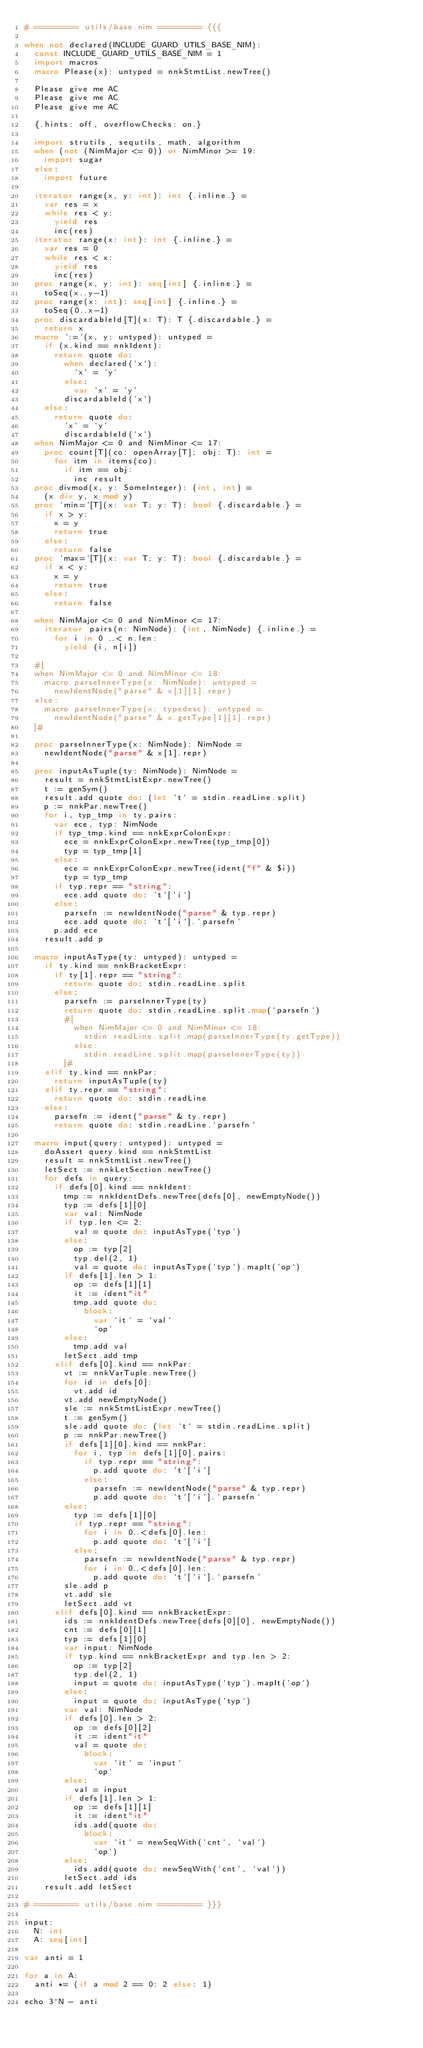Convert code to text. <code><loc_0><loc_0><loc_500><loc_500><_Nim_># ========= utils/base.nim ========= {{{

when not declared(INCLUDE_GUARD_UTILS_BASE_NIM):
  const INCLUDE_GUARD_UTILS_BASE_NIM = 1
  import macros
  macro Please(x): untyped = nnkStmtList.newTree()

  Please give me AC
  Please give me AC
  Please give me AC

  {.hints: off, overflowChecks: on.}

  import strutils, sequtils, math, algorithm
  when (not (NimMajor <= 0)) or NimMinor >= 19:
    import sugar
  else:
    import future

  iterator range(x, y: int): int {.inline.} =
    var res = x
    while res < y:
      yield res
      inc(res)
  iterator range(x: int): int {.inline.} =
    var res = 0
    while res < x:
      yield res
      inc(res)
  proc range(x, y: int): seq[int] {.inline.} =
    toSeq(x..y-1)
  proc range(x: int): seq[int] {.inline.} =
    toSeq(0..x-1)
  proc discardableId[T](x: T): T {.discardable.} =
    return x
  macro `:=`(x, y: untyped): untyped =
    if (x.kind == nnkIdent):
      return quote do:
        when declared(`x`):
          `x` = `y`
        else:
          var `x` = `y`
        discardableId(`x`)
    else:
      return quote do:
        `x` = `y`
        discardableId(`x`)
  when NimMajor <= 0 and NimMinor <= 17:
    proc count[T](co: openArray[T]; obj: T): int =
      for itm in items(co):
        if itm == obj:
          inc result
  proc divmod(x, y: SomeInteger): (int, int) =
    (x div y, x mod y)
  proc `min=`[T](x: var T; y: T): bool {.discardable.} =
    if x > y:
      x = y
      return true
    else:
      return false
  proc `max=`[T](x: var T; y: T): bool {.discardable.} =
    if x < y:
      x = y
      return true
    else:
      return false

  when NimMajor <= 0 and NimMinor <= 17:
    iterator pairs(n: NimNode): (int, NimNode) {.inline.} =
      for i in 0 ..< n.len:
        yield (i, n[i])

  #[
  when NimMajor <= 0 and NimMinor <= 18:
    macro parseInnerType(x: NimNode): untyped =
      newIdentNode("parse" & x[1][1].repr)
  else:
    macro parseInnerType(x: typedesc): untyped =
      newIdentNode("parse" & x.getType[1][1].repr)
  ]#

  proc parseInnerType(x: NimNode): NimNode =
    newIdentNode("parse" & x[1].repr)

  proc inputAsTuple(ty: NimNode): NimNode =
    result = nnkStmtListExpr.newTree()
    t := genSym()
    result.add quote do: (let `t` = stdin.readLine.split)
    p := nnkPar.newTree()
    for i, typ_tmp in ty.pairs:
      var ece, typ: NimNode
      if typ_tmp.kind == nnkExprColonExpr:
        ece = nnkExprColonExpr.newTree(typ_tmp[0])
        typ = typ_tmp[1]
      else:
        ece = nnkExprColonExpr.newTree(ident("f" & $i))
        typ = typ_tmp
      if typ.repr == "string":
        ece.add quote do: `t`[`i`]
      else:
        parsefn := newIdentNode("parse" & typ.repr)
        ece.add quote do: `t`[`i`].`parsefn`
      p.add ece
    result.add p

  macro inputAsType(ty: untyped): untyped =
    if ty.kind == nnkBracketExpr:
      if ty[1].repr == "string":
        return quote do: stdin.readLine.split
      else:
        parsefn := parseInnerType(ty)
        return quote do: stdin.readLine.split.map(`parsefn`)
        #[
          when NimMajor <= 0 and NimMinor <= 18:
            stdin.readLine.split.map(parseInnerType(ty.getType))
          else:
            stdin.readLine.split.map(parseInnerType(ty))
        ]#
    elif ty.kind == nnkPar:
      return inputAsTuple(ty)
    elif ty.repr == "string":
      return quote do: stdin.readLine
    else:
      parsefn := ident("parse" & ty.repr)
      return quote do: stdin.readLine.`parsefn`

  macro input(query: untyped): untyped =
    doAssert query.kind == nnkStmtList
    result = nnkStmtList.newTree()
    letSect := nnkLetSection.newTree()
    for defs in query:
      if defs[0].kind == nnkIdent:
        tmp := nnkIdentDefs.newTree(defs[0], newEmptyNode())
        typ := defs[1][0]
        var val: NimNode
        if typ.len <= 2:
          val = quote do: inputAsType(`typ`)
        else:
          op := typ[2]
          typ.del(2, 1)
          val = quote do: inputAsType(`typ`).mapIt(`op`)
        if defs[1].len > 1:
          op := defs[1][1]
          it := ident"it"
          tmp.add quote do:
            block:
              var `it` = `val`
              `op`
        else:
          tmp.add val
        letSect.add tmp
      elif defs[0].kind == nnkPar:
        vt := nnkVarTuple.newTree()
        for id in defs[0]:
          vt.add id
        vt.add newEmptyNode()
        sle := nnkStmtListExpr.newTree()
        t := genSym()
        sle.add quote do: (let `t` = stdin.readLine.split)
        p := nnkPar.newTree()
        if defs[1][0].kind == nnkPar:
          for i, typ in defs[1][0].pairs:
            if typ.repr == "string":
              p.add quote do: `t`[`i`]
            else:
              parsefn := newIdentNode("parse" & typ.repr)
              p.add quote do: `t`[`i`].`parsefn`
        else:
          typ := defs[1][0]
          if typ.repr == "string":
            for i in 0..<defs[0].len:
              p.add quote do: `t`[`i`]
          else:
            parsefn := newIdentNode("parse" & typ.repr)
            for i in 0..<defs[0].len:
              p.add quote do: `t`[`i`].`parsefn`
        sle.add p
        vt.add sle
        letSect.add vt
      elif defs[0].kind == nnkBracketExpr:
        ids := nnkIdentDefs.newTree(defs[0][0], newEmptyNode())
        cnt := defs[0][1]
        typ := defs[1][0]
        var input: NimNode
        if typ.kind == nnkBracketExpr and typ.len > 2:
          op := typ[2]
          typ.del(2, 1)
          input = quote do: inputAsType(`typ`).mapIt(`op`)
        else:
          input = quote do: inputAsType(`typ`)
        var val: NimNode
        if defs[0].len > 2:
          op := defs[0][2]
          it := ident"it"
          val = quote do:
            block:
              var `it` = `input`
              `op`
        else:
          val = input
        if defs[1].len > 1:
          op := defs[1][1]
          it := ident"it"
          ids.add(quote do:
            block:
              var `it` = newSeqWith(`cnt`, `val`)
              `op`)
        else:
          ids.add(quote do: newSeqWith(`cnt`, `val`))
        letSect.add ids
    result.add letSect

# ========= utils/base.nim ========= }}}

input:
  N: int
  A: seq[int]

var anti = 1

for a in A:
  anti *= (if a mod 2 == 0: 2 else: 1)

echo 3^N - anti
</code> 